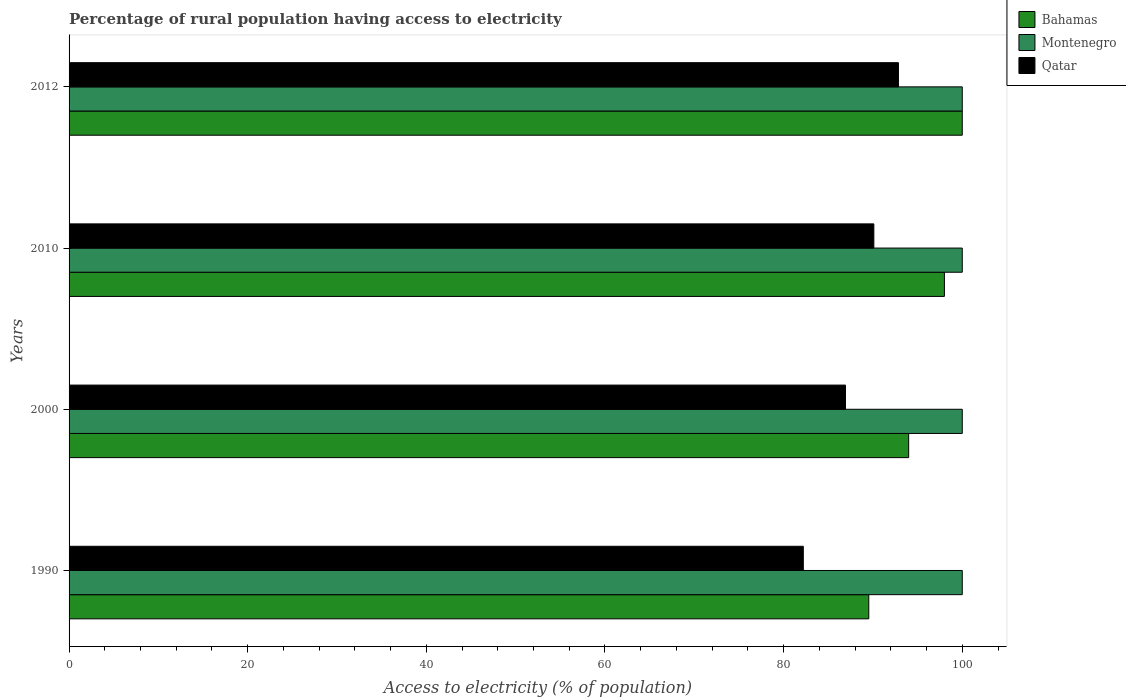How many different coloured bars are there?
Your answer should be compact. 3. Are the number of bars on each tick of the Y-axis equal?
Keep it short and to the point. Yes. How many bars are there on the 2nd tick from the top?
Your response must be concise. 3. How many bars are there on the 4th tick from the bottom?
Ensure brevity in your answer.  3. What is the percentage of rural population having access to electricity in Qatar in 2010?
Keep it short and to the point. 90.1. Across all years, what is the maximum percentage of rural population having access to electricity in Qatar?
Provide a succinct answer. 92.85. Across all years, what is the minimum percentage of rural population having access to electricity in Bahamas?
Make the answer very short. 89.53. In which year was the percentage of rural population having access to electricity in Montenegro maximum?
Ensure brevity in your answer.  1990. What is the total percentage of rural population having access to electricity in Montenegro in the graph?
Your response must be concise. 400. What is the difference between the percentage of rural population having access to electricity in Bahamas in 1990 and that in 2012?
Give a very brief answer. -10.47. What is the difference between the percentage of rural population having access to electricity in Bahamas in 1990 and the percentage of rural population having access to electricity in Qatar in 2012?
Your response must be concise. -3.32. What is the average percentage of rural population having access to electricity in Qatar per year?
Your answer should be very brief. 88.02. In the year 2000, what is the difference between the percentage of rural population having access to electricity in Montenegro and percentage of rural population having access to electricity in Qatar?
Keep it short and to the point. 13.07. In how many years, is the percentage of rural population having access to electricity in Montenegro greater than 92 %?
Make the answer very short. 4. Is the percentage of rural population having access to electricity in Bahamas in 1990 less than that in 2012?
Offer a terse response. Yes. What is the difference between the highest and the second highest percentage of rural population having access to electricity in Bahamas?
Make the answer very short. 2. What is the difference between the highest and the lowest percentage of rural population having access to electricity in Qatar?
Your answer should be compact. 10.65. In how many years, is the percentage of rural population having access to electricity in Montenegro greater than the average percentage of rural population having access to electricity in Montenegro taken over all years?
Your response must be concise. 0. Is the sum of the percentage of rural population having access to electricity in Montenegro in 1990 and 2000 greater than the maximum percentage of rural population having access to electricity in Bahamas across all years?
Make the answer very short. Yes. What does the 1st bar from the top in 1990 represents?
Your answer should be very brief. Qatar. What does the 2nd bar from the bottom in 2012 represents?
Ensure brevity in your answer.  Montenegro. Is it the case that in every year, the sum of the percentage of rural population having access to electricity in Montenegro and percentage of rural population having access to electricity in Bahamas is greater than the percentage of rural population having access to electricity in Qatar?
Keep it short and to the point. Yes. Are all the bars in the graph horizontal?
Give a very brief answer. Yes. How many years are there in the graph?
Make the answer very short. 4. Are the values on the major ticks of X-axis written in scientific E-notation?
Keep it short and to the point. No. Does the graph contain any zero values?
Make the answer very short. No. Does the graph contain grids?
Offer a very short reply. No. How many legend labels are there?
Provide a short and direct response. 3. What is the title of the graph?
Give a very brief answer. Percentage of rural population having access to electricity. Does "Bolivia" appear as one of the legend labels in the graph?
Provide a short and direct response. No. What is the label or title of the X-axis?
Keep it short and to the point. Access to electricity (% of population). What is the label or title of the Y-axis?
Offer a very short reply. Years. What is the Access to electricity (% of population) of Bahamas in 1990?
Offer a very short reply. 89.53. What is the Access to electricity (% of population) of Montenegro in 1990?
Offer a terse response. 100. What is the Access to electricity (% of population) of Qatar in 1990?
Keep it short and to the point. 82.2. What is the Access to electricity (% of population) in Bahamas in 2000?
Your answer should be compact. 94. What is the Access to electricity (% of population) of Montenegro in 2000?
Provide a short and direct response. 100. What is the Access to electricity (% of population) of Qatar in 2000?
Ensure brevity in your answer.  86.93. What is the Access to electricity (% of population) of Montenegro in 2010?
Your response must be concise. 100. What is the Access to electricity (% of population) in Qatar in 2010?
Provide a succinct answer. 90.1. What is the Access to electricity (% of population) of Qatar in 2012?
Keep it short and to the point. 92.85. Across all years, what is the maximum Access to electricity (% of population) of Qatar?
Offer a very short reply. 92.85. Across all years, what is the minimum Access to electricity (% of population) of Bahamas?
Make the answer very short. 89.53. Across all years, what is the minimum Access to electricity (% of population) of Qatar?
Offer a very short reply. 82.2. What is the total Access to electricity (% of population) of Bahamas in the graph?
Provide a succinct answer. 381.53. What is the total Access to electricity (% of population) in Qatar in the graph?
Your response must be concise. 352.08. What is the difference between the Access to electricity (% of population) in Bahamas in 1990 and that in 2000?
Your response must be concise. -4.47. What is the difference between the Access to electricity (% of population) of Montenegro in 1990 and that in 2000?
Offer a terse response. 0. What is the difference between the Access to electricity (% of population) of Qatar in 1990 and that in 2000?
Your answer should be compact. -4.72. What is the difference between the Access to electricity (% of population) of Bahamas in 1990 and that in 2010?
Make the answer very short. -8.47. What is the difference between the Access to electricity (% of population) in Qatar in 1990 and that in 2010?
Offer a terse response. -7.9. What is the difference between the Access to electricity (% of population) in Bahamas in 1990 and that in 2012?
Make the answer very short. -10.47. What is the difference between the Access to electricity (% of population) in Montenegro in 1990 and that in 2012?
Keep it short and to the point. 0. What is the difference between the Access to electricity (% of population) of Qatar in 1990 and that in 2012?
Offer a very short reply. -10.65. What is the difference between the Access to electricity (% of population) of Montenegro in 2000 and that in 2010?
Keep it short and to the point. 0. What is the difference between the Access to electricity (% of population) in Qatar in 2000 and that in 2010?
Your answer should be very brief. -3.17. What is the difference between the Access to electricity (% of population) of Montenegro in 2000 and that in 2012?
Keep it short and to the point. 0. What is the difference between the Access to electricity (% of population) of Qatar in 2000 and that in 2012?
Your answer should be compact. -5.93. What is the difference between the Access to electricity (% of population) of Qatar in 2010 and that in 2012?
Offer a terse response. -2.75. What is the difference between the Access to electricity (% of population) in Bahamas in 1990 and the Access to electricity (% of population) in Montenegro in 2000?
Your answer should be very brief. -10.47. What is the difference between the Access to electricity (% of population) in Bahamas in 1990 and the Access to electricity (% of population) in Qatar in 2000?
Offer a very short reply. 2.61. What is the difference between the Access to electricity (% of population) in Montenegro in 1990 and the Access to electricity (% of population) in Qatar in 2000?
Your answer should be compact. 13.07. What is the difference between the Access to electricity (% of population) of Bahamas in 1990 and the Access to electricity (% of population) of Montenegro in 2010?
Provide a succinct answer. -10.47. What is the difference between the Access to electricity (% of population) of Bahamas in 1990 and the Access to electricity (% of population) of Qatar in 2010?
Offer a very short reply. -0.57. What is the difference between the Access to electricity (% of population) of Bahamas in 1990 and the Access to electricity (% of population) of Montenegro in 2012?
Your answer should be very brief. -10.47. What is the difference between the Access to electricity (% of population) of Bahamas in 1990 and the Access to electricity (% of population) of Qatar in 2012?
Offer a very short reply. -3.32. What is the difference between the Access to electricity (% of population) in Montenegro in 1990 and the Access to electricity (% of population) in Qatar in 2012?
Ensure brevity in your answer.  7.15. What is the difference between the Access to electricity (% of population) in Bahamas in 2000 and the Access to electricity (% of population) in Qatar in 2010?
Your response must be concise. 3.9. What is the difference between the Access to electricity (% of population) in Montenegro in 2000 and the Access to electricity (% of population) in Qatar in 2010?
Ensure brevity in your answer.  9.9. What is the difference between the Access to electricity (% of population) of Bahamas in 2000 and the Access to electricity (% of population) of Montenegro in 2012?
Your answer should be compact. -6. What is the difference between the Access to electricity (% of population) of Bahamas in 2000 and the Access to electricity (% of population) of Qatar in 2012?
Offer a very short reply. 1.15. What is the difference between the Access to electricity (% of population) in Montenegro in 2000 and the Access to electricity (% of population) in Qatar in 2012?
Your response must be concise. 7.15. What is the difference between the Access to electricity (% of population) in Bahamas in 2010 and the Access to electricity (% of population) in Qatar in 2012?
Ensure brevity in your answer.  5.15. What is the difference between the Access to electricity (% of population) in Montenegro in 2010 and the Access to electricity (% of population) in Qatar in 2012?
Your answer should be compact. 7.15. What is the average Access to electricity (% of population) of Bahamas per year?
Offer a terse response. 95.38. What is the average Access to electricity (% of population) of Qatar per year?
Provide a short and direct response. 88.02. In the year 1990, what is the difference between the Access to electricity (% of population) in Bahamas and Access to electricity (% of population) in Montenegro?
Give a very brief answer. -10.47. In the year 1990, what is the difference between the Access to electricity (% of population) of Bahamas and Access to electricity (% of population) of Qatar?
Make the answer very short. 7.33. In the year 1990, what is the difference between the Access to electricity (% of population) of Montenegro and Access to electricity (% of population) of Qatar?
Your response must be concise. 17.8. In the year 2000, what is the difference between the Access to electricity (% of population) in Bahamas and Access to electricity (% of population) in Montenegro?
Provide a succinct answer. -6. In the year 2000, what is the difference between the Access to electricity (% of population) in Bahamas and Access to electricity (% of population) in Qatar?
Your answer should be very brief. 7.07. In the year 2000, what is the difference between the Access to electricity (% of population) in Montenegro and Access to electricity (% of population) in Qatar?
Make the answer very short. 13.07. In the year 2010, what is the difference between the Access to electricity (% of population) of Montenegro and Access to electricity (% of population) of Qatar?
Offer a very short reply. 9.9. In the year 2012, what is the difference between the Access to electricity (% of population) in Bahamas and Access to electricity (% of population) in Montenegro?
Your answer should be compact. 0. In the year 2012, what is the difference between the Access to electricity (% of population) in Bahamas and Access to electricity (% of population) in Qatar?
Give a very brief answer. 7.15. In the year 2012, what is the difference between the Access to electricity (% of population) in Montenegro and Access to electricity (% of population) in Qatar?
Make the answer very short. 7.15. What is the ratio of the Access to electricity (% of population) in Bahamas in 1990 to that in 2000?
Give a very brief answer. 0.95. What is the ratio of the Access to electricity (% of population) of Qatar in 1990 to that in 2000?
Make the answer very short. 0.95. What is the ratio of the Access to electricity (% of population) in Bahamas in 1990 to that in 2010?
Make the answer very short. 0.91. What is the ratio of the Access to electricity (% of population) in Qatar in 1990 to that in 2010?
Offer a terse response. 0.91. What is the ratio of the Access to electricity (% of population) in Bahamas in 1990 to that in 2012?
Your response must be concise. 0.9. What is the ratio of the Access to electricity (% of population) of Montenegro in 1990 to that in 2012?
Provide a short and direct response. 1. What is the ratio of the Access to electricity (% of population) of Qatar in 1990 to that in 2012?
Offer a very short reply. 0.89. What is the ratio of the Access to electricity (% of population) of Bahamas in 2000 to that in 2010?
Give a very brief answer. 0.96. What is the ratio of the Access to electricity (% of population) of Montenegro in 2000 to that in 2010?
Make the answer very short. 1. What is the ratio of the Access to electricity (% of population) in Qatar in 2000 to that in 2010?
Offer a terse response. 0.96. What is the ratio of the Access to electricity (% of population) of Qatar in 2000 to that in 2012?
Provide a short and direct response. 0.94. What is the ratio of the Access to electricity (% of population) of Bahamas in 2010 to that in 2012?
Your answer should be compact. 0.98. What is the ratio of the Access to electricity (% of population) in Montenegro in 2010 to that in 2012?
Ensure brevity in your answer.  1. What is the ratio of the Access to electricity (% of population) in Qatar in 2010 to that in 2012?
Your answer should be compact. 0.97. What is the difference between the highest and the second highest Access to electricity (% of population) in Qatar?
Make the answer very short. 2.75. What is the difference between the highest and the lowest Access to electricity (% of population) of Bahamas?
Offer a terse response. 10.47. What is the difference between the highest and the lowest Access to electricity (% of population) of Qatar?
Make the answer very short. 10.65. 